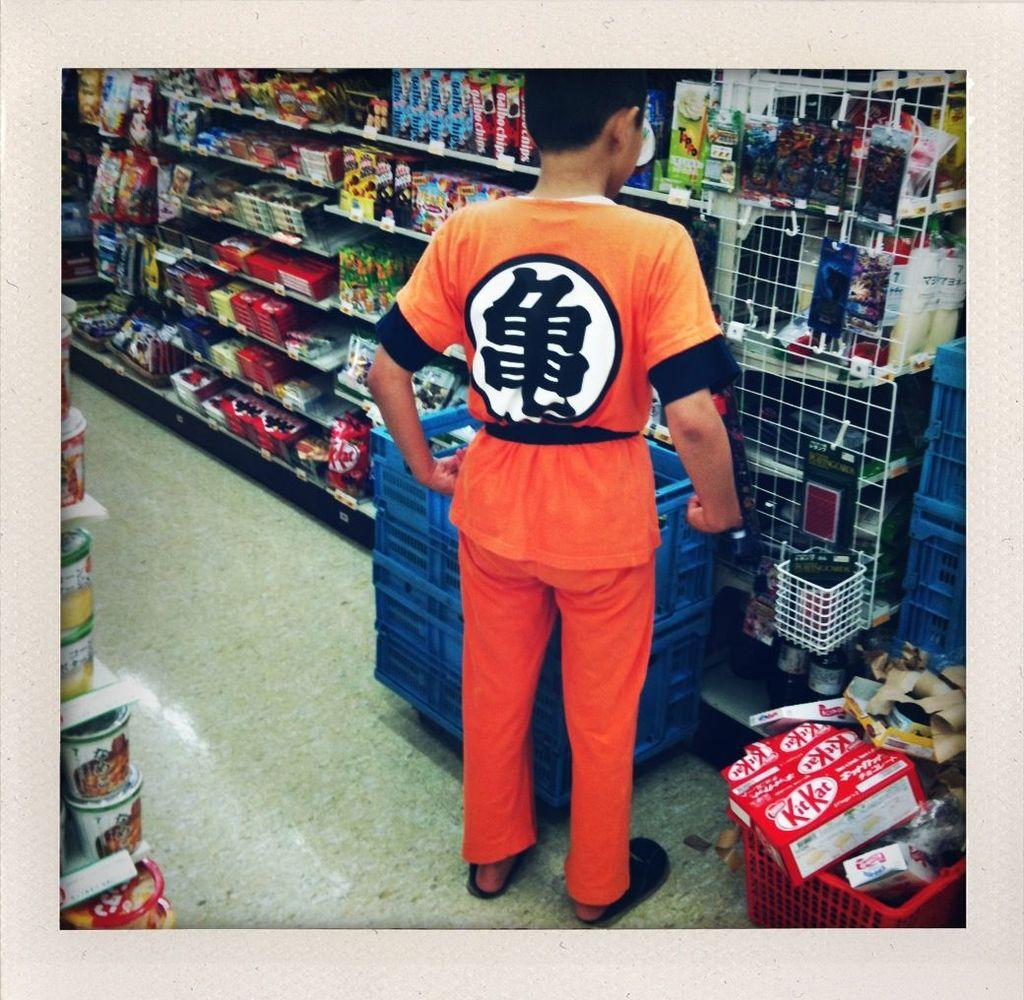Provide a one-sentence caption for the provided image. A boy in orange strolls a store aisle with Kit Kats in his basket. 